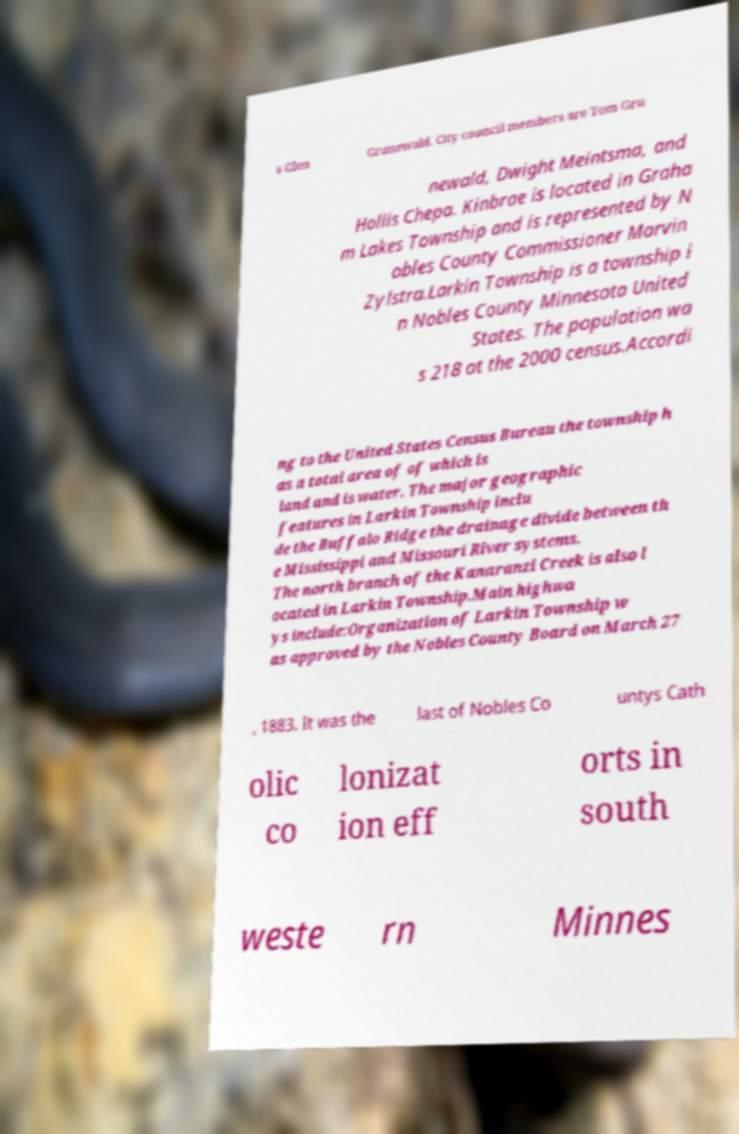Could you assist in decoding the text presented in this image and type it out clearly? s Glen Grunewald. City council members are Tom Gru newald, Dwight Meintsma, and Hollis Chepa. Kinbrae is located in Graha m Lakes Township and is represented by N obles County Commissioner Marvin Zylstra.Larkin Township is a township i n Nobles County Minnesota United States. The population wa s 218 at the 2000 census.Accordi ng to the United States Census Bureau the township h as a total area of of which is land and is water. The major geographic features in Larkin Township inclu de the Buffalo Ridge the drainage divide between th e Mississippi and Missouri River systems. The north branch of the Kanaranzi Creek is also l ocated in Larkin Township.Main highwa ys include:Organization of Larkin Township w as approved by the Nobles County Board on March 27 , 1883. It was the last of Nobles Co untys Cath olic co lonizat ion eff orts in south weste rn Minnes 